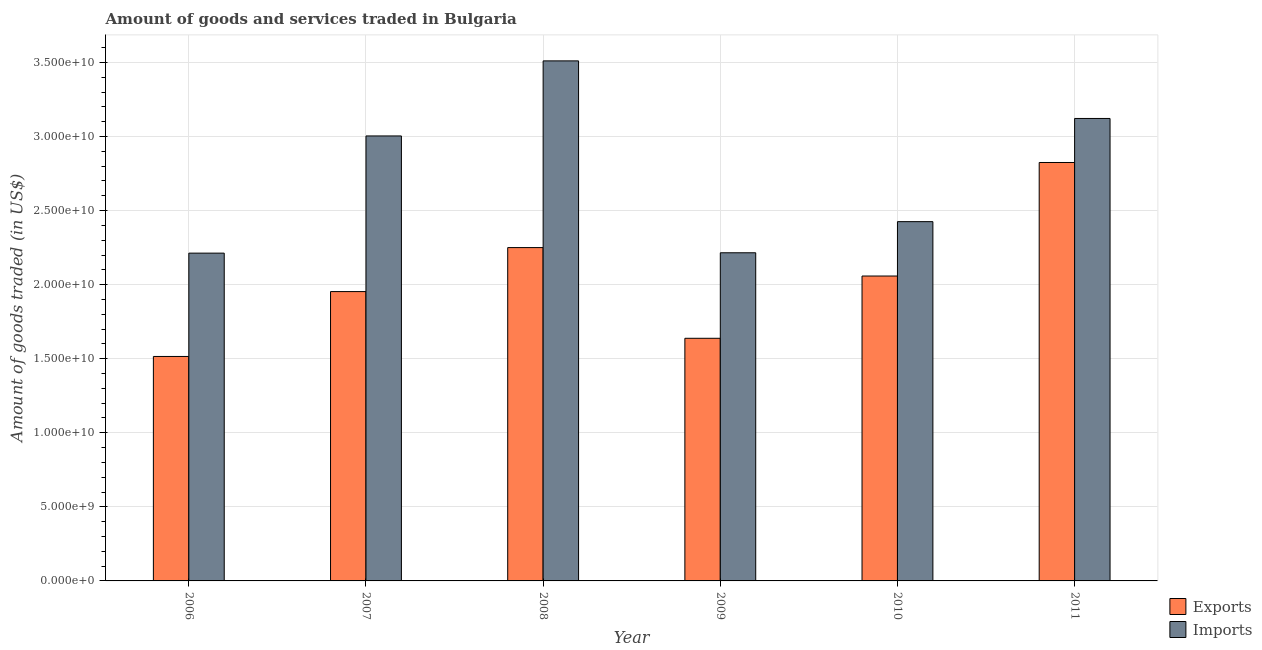Are the number of bars per tick equal to the number of legend labels?
Offer a very short reply. Yes. Are the number of bars on each tick of the X-axis equal?
Provide a short and direct response. Yes. What is the label of the 4th group of bars from the left?
Make the answer very short. 2009. In how many cases, is the number of bars for a given year not equal to the number of legend labels?
Provide a succinct answer. 0. What is the amount of goods imported in 2007?
Your response must be concise. 3.00e+1. Across all years, what is the maximum amount of goods exported?
Keep it short and to the point. 2.82e+1. Across all years, what is the minimum amount of goods imported?
Offer a very short reply. 2.21e+1. What is the total amount of goods exported in the graph?
Keep it short and to the point. 1.22e+11. What is the difference between the amount of goods exported in 2006 and that in 2007?
Ensure brevity in your answer.  -4.38e+09. What is the difference between the amount of goods imported in 2010 and the amount of goods exported in 2007?
Give a very brief answer. -5.79e+09. What is the average amount of goods imported per year?
Give a very brief answer. 2.75e+1. In how many years, is the amount of goods imported greater than 29000000000 US$?
Provide a succinct answer. 3. What is the ratio of the amount of goods imported in 2007 to that in 2009?
Give a very brief answer. 1.36. Is the amount of goods exported in 2006 less than that in 2007?
Offer a terse response. Yes. Is the difference between the amount of goods imported in 2006 and 2007 greater than the difference between the amount of goods exported in 2006 and 2007?
Offer a very short reply. No. What is the difference between the highest and the second highest amount of goods exported?
Your response must be concise. 5.74e+09. What is the difference between the highest and the lowest amount of goods exported?
Your answer should be compact. 1.31e+1. In how many years, is the amount of goods exported greater than the average amount of goods exported taken over all years?
Give a very brief answer. 3. Is the sum of the amount of goods exported in 2008 and 2010 greater than the maximum amount of goods imported across all years?
Keep it short and to the point. Yes. What does the 1st bar from the left in 2006 represents?
Provide a succinct answer. Exports. What does the 2nd bar from the right in 2009 represents?
Make the answer very short. Exports. How many bars are there?
Your response must be concise. 12. Are all the bars in the graph horizontal?
Offer a terse response. No. What is the difference between two consecutive major ticks on the Y-axis?
Provide a short and direct response. 5.00e+09. Does the graph contain grids?
Give a very brief answer. Yes. How many legend labels are there?
Offer a terse response. 2. How are the legend labels stacked?
Provide a succinct answer. Vertical. What is the title of the graph?
Provide a succinct answer. Amount of goods and services traded in Bulgaria. What is the label or title of the Y-axis?
Make the answer very short. Amount of goods traded (in US$). What is the Amount of goods traded (in US$) of Exports in 2006?
Ensure brevity in your answer.  1.52e+1. What is the Amount of goods traded (in US$) in Imports in 2006?
Your response must be concise. 2.21e+1. What is the Amount of goods traded (in US$) in Exports in 2007?
Keep it short and to the point. 1.95e+1. What is the Amount of goods traded (in US$) of Imports in 2007?
Your response must be concise. 3.00e+1. What is the Amount of goods traded (in US$) in Exports in 2008?
Offer a terse response. 2.25e+1. What is the Amount of goods traded (in US$) of Imports in 2008?
Offer a very short reply. 3.51e+1. What is the Amount of goods traded (in US$) in Exports in 2009?
Ensure brevity in your answer.  1.64e+1. What is the Amount of goods traded (in US$) in Imports in 2009?
Your answer should be very brief. 2.22e+1. What is the Amount of goods traded (in US$) in Exports in 2010?
Your answer should be compact. 2.06e+1. What is the Amount of goods traded (in US$) of Imports in 2010?
Offer a very short reply. 2.43e+1. What is the Amount of goods traded (in US$) in Exports in 2011?
Give a very brief answer. 2.82e+1. What is the Amount of goods traded (in US$) in Imports in 2011?
Provide a short and direct response. 3.12e+1. Across all years, what is the maximum Amount of goods traded (in US$) of Exports?
Your answer should be very brief. 2.82e+1. Across all years, what is the maximum Amount of goods traded (in US$) of Imports?
Offer a terse response. 3.51e+1. Across all years, what is the minimum Amount of goods traded (in US$) in Exports?
Provide a succinct answer. 1.52e+1. Across all years, what is the minimum Amount of goods traded (in US$) of Imports?
Ensure brevity in your answer.  2.21e+1. What is the total Amount of goods traded (in US$) of Exports in the graph?
Offer a very short reply. 1.22e+11. What is the total Amount of goods traded (in US$) of Imports in the graph?
Provide a short and direct response. 1.65e+11. What is the difference between the Amount of goods traded (in US$) of Exports in 2006 and that in 2007?
Your answer should be compact. -4.38e+09. What is the difference between the Amount of goods traded (in US$) in Imports in 2006 and that in 2007?
Offer a very short reply. -7.91e+09. What is the difference between the Amount of goods traded (in US$) of Exports in 2006 and that in 2008?
Keep it short and to the point. -7.35e+09. What is the difference between the Amount of goods traded (in US$) in Imports in 2006 and that in 2008?
Ensure brevity in your answer.  -1.30e+1. What is the difference between the Amount of goods traded (in US$) in Exports in 2006 and that in 2009?
Provide a succinct answer. -1.23e+09. What is the difference between the Amount of goods traded (in US$) in Imports in 2006 and that in 2009?
Keep it short and to the point. -2.38e+07. What is the difference between the Amount of goods traded (in US$) in Exports in 2006 and that in 2010?
Your answer should be very brief. -5.43e+09. What is the difference between the Amount of goods traded (in US$) in Imports in 2006 and that in 2010?
Make the answer very short. -2.13e+09. What is the difference between the Amount of goods traded (in US$) of Exports in 2006 and that in 2011?
Give a very brief answer. -1.31e+1. What is the difference between the Amount of goods traded (in US$) of Imports in 2006 and that in 2011?
Your response must be concise. -9.09e+09. What is the difference between the Amount of goods traded (in US$) in Exports in 2007 and that in 2008?
Your answer should be compact. -2.97e+09. What is the difference between the Amount of goods traded (in US$) in Imports in 2007 and that in 2008?
Provide a short and direct response. -5.07e+09. What is the difference between the Amount of goods traded (in US$) in Exports in 2007 and that in 2009?
Your response must be concise. 3.15e+09. What is the difference between the Amount of goods traded (in US$) of Imports in 2007 and that in 2009?
Offer a terse response. 7.89e+09. What is the difference between the Amount of goods traded (in US$) in Exports in 2007 and that in 2010?
Make the answer very short. -1.05e+09. What is the difference between the Amount of goods traded (in US$) of Imports in 2007 and that in 2010?
Make the answer very short. 5.79e+09. What is the difference between the Amount of goods traded (in US$) of Exports in 2007 and that in 2011?
Your answer should be very brief. -8.71e+09. What is the difference between the Amount of goods traded (in US$) in Imports in 2007 and that in 2011?
Offer a very short reply. -1.18e+09. What is the difference between the Amount of goods traded (in US$) in Exports in 2008 and that in 2009?
Give a very brief answer. 6.12e+09. What is the difference between the Amount of goods traded (in US$) in Imports in 2008 and that in 2009?
Make the answer very short. 1.30e+1. What is the difference between the Amount of goods traded (in US$) in Exports in 2008 and that in 2010?
Your response must be concise. 1.92e+09. What is the difference between the Amount of goods traded (in US$) in Imports in 2008 and that in 2010?
Ensure brevity in your answer.  1.09e+1. What is the difference between the Amount of goods traded (in US$) of Exports in 2008 and that in 2011?
Offer a very short reply. -5.74e+09. What is the difference between the Amount of goods traded (in US$) in Imports in 2008 and that in 2011?
Offer a very short reply. 3.89e+09. What is the difference between the Amount of goods traded (in US$) in Exports in 2009 and that in 2010?
Your answer should be compact. -4.20e+09. What is the difference between the Amount of goods traded (in US$) of Imports in 2009 and that in 2010?
Provide a succinct answer. -2.10e+09. What is the difference between the Amount of goods traded (in US$) in Exports in 2009 and that in 2011?
Provide a short and direct response. -1.19e+1. What is the difference between the Amount of goods traded (in US$) in Imports in 2009 and that in 2011?
Give a very brief answer. -9.07e+09. What is the difference between the Amount of goods traded (in US$) in Exports in 2010 and that in 2011?
Offer a very short reply. -7.66e+09. What is the difference between the Amount of goods traded (in US$) in Imports in 2010 and that in 2011?
Your answer should be compact. -6.97e+09. What is the difference between the Amount of goods traded (in US$) in Exports in 2006 and the Amount of goods traded (in US$) in Imports in 2007?
Keep it short and to the point. -1.49e+1. What is the difference between the Amount of goods traded (in US$) of Exports in 2006 and the Amount of goods traded (in US$) of Imports in 2008?
Keep it short and to the point. -2.00e+1. What is the difference between the Amount of goods traded (in US$) in Exports in 2006 and the Amount of goods traded (in US$) in Imports in 2009?
Offer a terse response. -7.00e+09. What is the difference between the Amount of goods traded (in US$) in Exports in 2006 and the Amount of goods traded (in US$) in Imports in 2010?
Your answer should be compact. -9.10e+09. What is the difference between the Amount of goods traded (in US$) in Exports in 2006 and the Amount of goods traded (in US$) in Imports in 2011?
Offer a terse response. -1.61e+1. What is the difference between the Amount of goods traded (in US$) of Exports in 2007 and the Amount of goods traded (in US$) of Imports in 2008?
Ensure brevity in your answer.  -1.56e+1. What is the difference between the Amount of goods traded (in US$) of Exports in 2007 and the Amount of goods traded (in US$) of Imports in 2009?
Offer a very short reply. -2.62e+09. What is the difference between the Amount of goods traded (in US$) in Exports in 2007 and the Amount of goods traded (in US$) in Imports in 2010?
Your response must be concise. -4.72e+09. What is the difference between the Amount of goods traded (in US$) in Exports in 2007 and the Amount of goods traded (in US$) in Imports in 2011?
Provide a succinct answer. -1.17e+1. What is the difference between the Amount of goods traded (in US$) of Exports in 2008 and the Amount of goods traded (in US$) of Imports in 2009?
Give a very brief answer. 3.50e+08. What is the difference between the Amount of goods traded (in US$) in Exports in 2008 and the Amount of goods traded (in US$) in Imports in 2010?
Keep it short and to the point. -1.75e+09. What is the difference between the Amount of goods traded (in US$) in Exports in 2008 and the Amount of goods traded (in US$) in Imports in 2011?
Offer a very short reply. -8.72e+09. What is the difference between the Amount of goods traded (in US$) in Exports in 2009 and the Amount of goods traded (in US$) in Imports in 2010?
Provide a succinct answer. -7.88e+09. What is the difference between the Amount of goods traded (in US$) in Exports in 2009 and the Amount of goods traded (in US$) in Imports in 2011?
Make the answer very short. -1.48e+1. What is the difference between the Amount of goods traded (in US$) of Exports in 2010 and the Amount of goods traded (in US$) of Imports in 2011?
Give a very brief answer. -1.06e+1. What is the average Amount of goods traded (in US$) of Exports per year?
Ensure brevity in your answer.  2.04e+1. What is the average Amount of goods traded (in US$) of Imports per year?
Your answer should be very brief. 2.75e+1. In the year 2006, what is the difference between the Amount of goods traded (in US$) in Exports and Amount of goods traded (in US$) in Imports?
Make the answer very short. -6.98e+09. In the year 2007, what is the difference between the Amount of goods traded (in US$) of Exports and Amount of goods traded (in US$) of Imports?
Provide a short and direct response. -1.05e+1. In the year 2008, what is the difference between the Amount of goods traded (in US$) of Exports and Amount of goods traded (in US$) of Imports?
Give a very brief answer. -1.26e+1. In the year 2009, what is the difference between the Amount of goods traded (in US$) in Exports and Amount of goods traded (in US$) in Imports?
Your response must be concise. -5.77e+09. In the year 2010, what is the difference between the Amount of goods traded (in US$) in Exports and Amount of goods traded (in US$) in Imports?
Your response must be concise. -3.67e+09. In the year 2011, what is the difference between the Amount of goods traded (in US$) in Exports and Amount of goods traded (in US$) in Imports?
Provide a succinct answer. -2.97e+09. What is the ratio of the Amount of goods traded (in US$) of Exports in 2006 to that in 2007?
Offer a very short reply. 0.78. What is the ratio of the Amount of goods traded (in US$) of Imports in 2006 to that in 2007?
Make the answer very short. 0.74. What is the ratio of the Amount of goods traded (in US$) in Exports in 2006 to that in 2008?
Your answer should be compact. 0.67. What is the ratio of the Amount of goods traded (in US$) in Imports in 2006 to that in 2008?
Give a very brief answer. 0.63. What is the ratio of the Amount of goods traded (in US$) of Exports in 2006 to that in 2009?
Your answer should be very brief. 0.93. What is the ratio of the Amount of goods traded (in US$) of Exports in 2006 to that in 2010?
Give a very brief answer. 0.74. What is the ratio of the Amount of goods traded (in US$) in Imports in 2006 to that in 2010?
Offer a terse response. 0.91. What is the ratio of the Amount of goods traded (in US$) of Exports in 2006 to that in 2011?
Your answer should be very brief. 0.54. What is the ratio of the Amount of goods traded (in US$) of Imports in 2006 to that in 2011?
Give a very brief answer. 0.71. What is the ratio of the Amount of goods traded (in US$) in Exports in 2007 to that in 2008?
Offer a very short reply. 0.87. What is the ratio of the Amount of goods traded (in US$) in Imports in 2007 to that in 2008?
Your answer should be compact. 0.86. What is the ratio of the Amount of goods traded (in US$) in Exports in 2007 to that in 2009?
Give a very brief answer. 1.19. What is the ratio of the Amount of goods traded (in US$) in Imports in 2007 to that in 2009?
Ensure brevity in your answer.  1.36. What is the ratio of the Amount of goods traded (in US$) in Exports in 2007 to that in 2010?
Offer a very short reply. 0.95. What is the ratio of the Amount of goods traded (in US$) in Imports in 2007 to that in 2010?
Provide a succinct answer. 1.24. What is the ratio of the Amount of goods traded (in US$) of Exports in 2007 to that in 2011?
Your response must be concise. 0.69. What is the ratio of the Amount of goods traded (in US$) of Imports in 2007 to that in 2011?
Your response must be concise. 0.96. What is the ratio of the Amount of goods traded (in US$) of Exports in 2008 to that in 2009?
Provide a succinct answer. 1.37. What is the ratio of the Amount of goods traded (in US$) of Imports in 2008 to that in 2009?
Your response must be concise. 1.58. What is the ratio of the Amount of goods traded (in US$) of Exports in 2008 to that in 2010?
Offer a terse response. 1.09. What is the ratio of the Amount of goods traded (in US$) in Imports in 2008 to that in 2010?
Provide a succinct answer. 1.45. What is the ratio of the Amount of goods traded (in US$) of Exports in 2008 to that in 2011?
Ensure brevity in your answer.  0.8. What is the ratio of the Amount of goods traded (in US$) of Imports in 2008 to that in 2011?
Provide a succinct answer. 1.12. What is the ratio of the Amount of goods traded (in US$) of Exports in 2009 to that in 2010?
Make the answer very short. 0.8. What is the ratio of the Amount of goods traded (in US$) of Imports in 2009 to that in 2010?
Ensure brevity in your answer.  0.91. What is the ratio of the Amount of goods traded (in US$) in Exports in 2009 to that in 2011?
Provide a short and direct response. 0.58. What is the ratio of the Amount of goods traded (in US$) of Imports in 2009 to that in 2011?
Provide a short and direct response. 0.71. What is the ratio of the Amount of goods traded (in US$) of Exports in 2010 to that in 2011?
Your answer should be compact. 0.73. What is the ratio of the Amount of goods traded (in US$) in Imports in 2010 to that in 2011?
Keep it short and to the point. 0.78. What is the difference between the highest and the second highest Amount of goods traded (in US$) in Exports?
Keep it short and to the point. 5.74e+09. What is the difference between the highest and the second highest Amount of goods traded (in US$) in Imports?
Your answer should be compact. 3.89e+09. What is the difference between the highest and the lowest Amount of goods traded (in US$) of Exports?
Keep it short and to the point. 1.31e+1. What is the difference between the highest and the lowest Amount of goods traded (in US$) in Imports?
Give a very brief answer. 1.30e+1. 